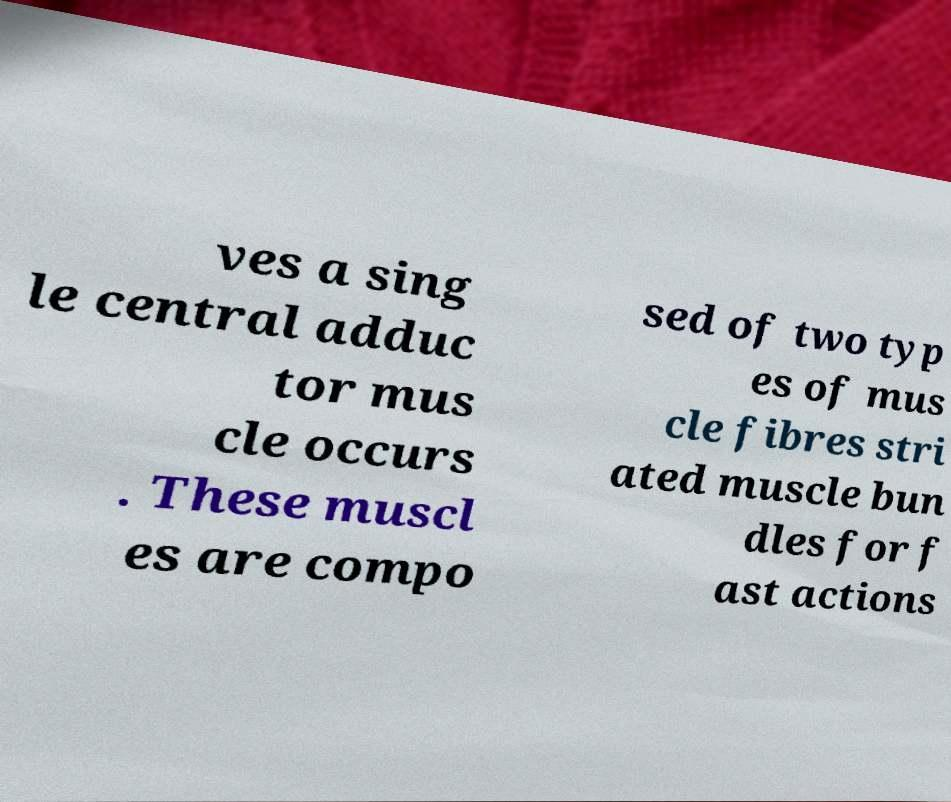Can you read and provide the text displayed in the image?This photo seems to have some interesting text. Can you extract and type it out for me? ves a sing le central adduc tor mus cle occurs . These muscl es are compo sed of two typ es of mus cle fibres stri ated muscle bun dles for f ast actions 